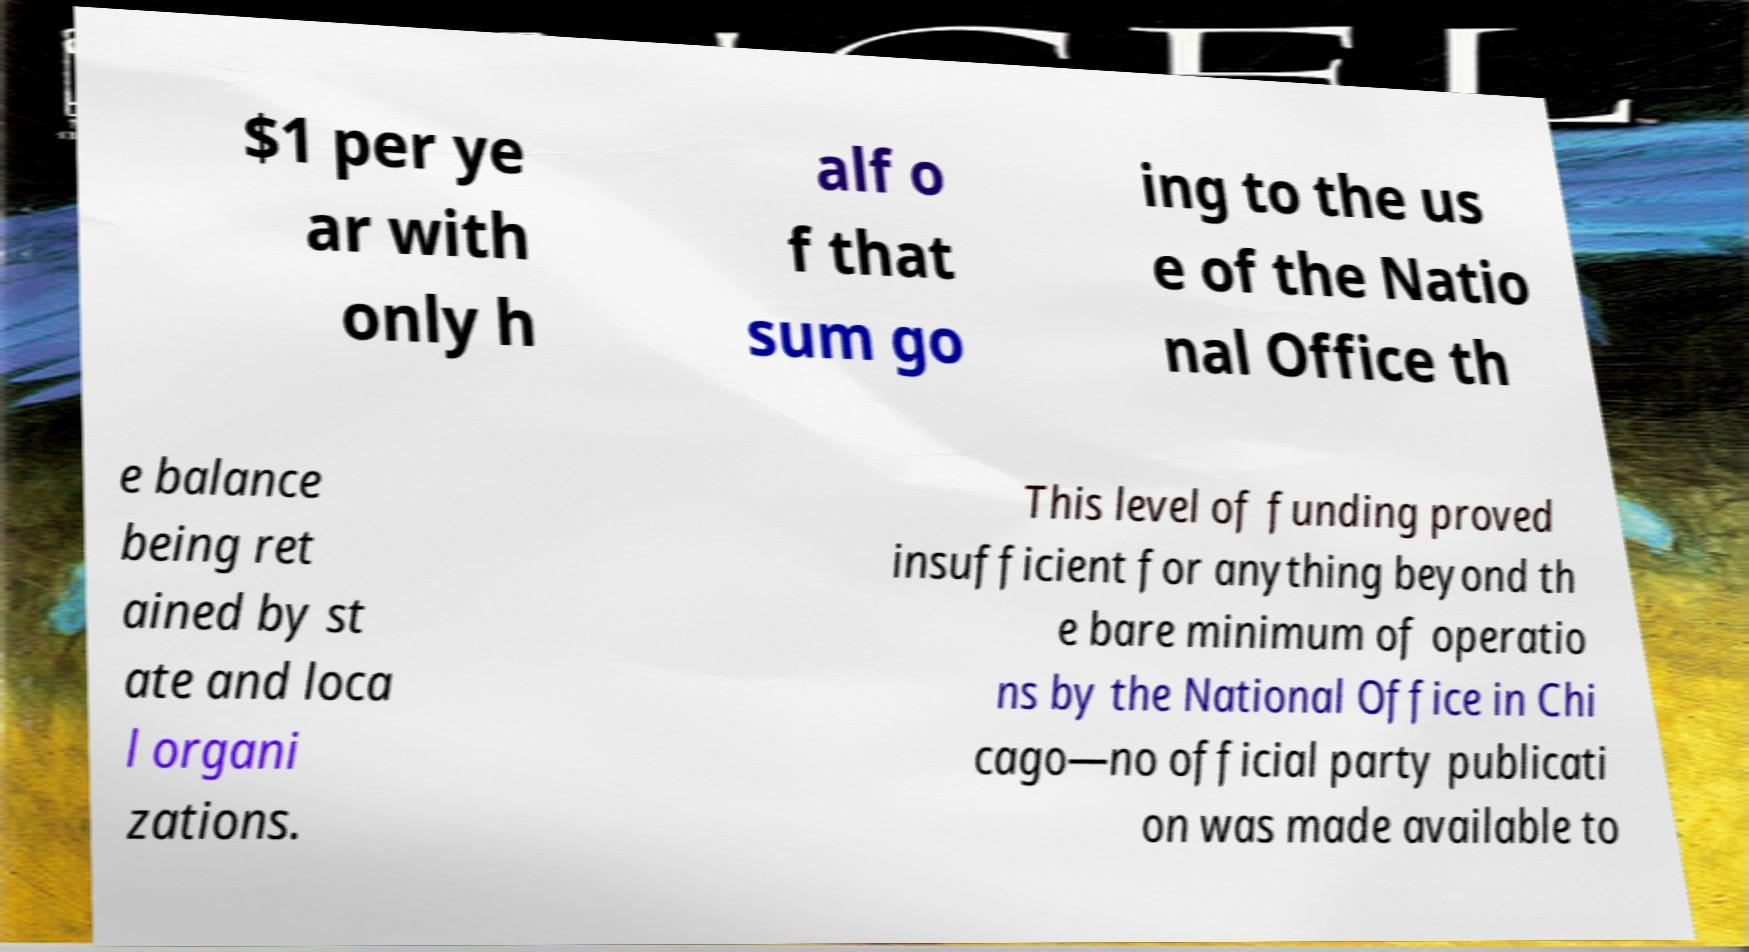There's text embedded in this image that I need extracted. Can you transcribe it verbatim? $1 per ye ar with only h alf o f that sum go ing to the us e of the Natio nal Office th e balance being ret ained by st ate and loca l organi zations. This level of funding proved insufficient for anything beyond th e bare minimum of operatio ns by the National Office in Chi cago—no official party publicati on was made available to 